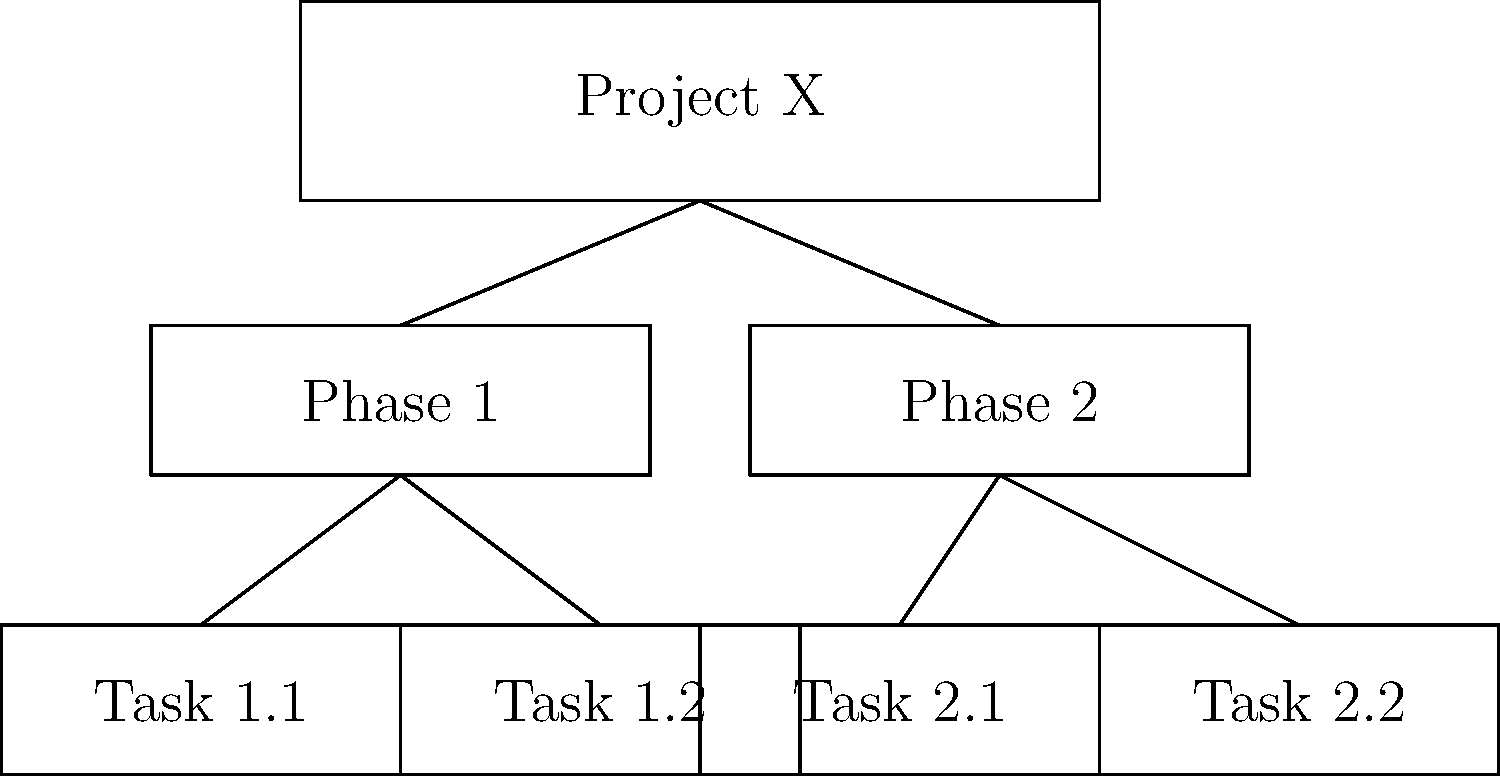In the given Work Breakdown Structure (WBS) diagram for Project X, how many levels of hierarchy are represented, and what is the total number of tasks at the lowest level? To answer this question, let's analyze the WBS diagram step-by-step:

1. Identify the levels of hierarchy:
   - Level 1: Project X (top level)
   - Level 2: Phase 1 and Phase 2
   - Level 3: Tasks 1.1, 1.2, 2.1, and 2.2

2. Count the number of levels:
   There are 3 distinct levels in this WBS.

3. Identify the lowest level:
   The lowest level consists of the individual tasks (1.1, 1.2, 2.1, and 2.2).

4. Count the number of tasks at the lowest level:
   There are 4 tasks at the lowest level (Level 3).

Therefore, the WBS diagram represents 3 levels of hierarchy, and there are 4 tasks at the lowest level.
Answer: 3 levels, 4 tasks 